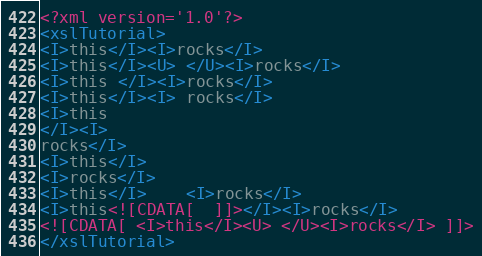Convert code to text. <code><loc_0><loc_0><loc_500><loc_500><_XML_><?xml version='1.0'?>
<xslTutorial>
<I>this</I><I>rocks</I>
<I>this</I><U> </U><I>rocks</I>
<I>this </I><I>rocks</I>
<I>this</I><I> rocks</I>
<I>this
</I><I>
rocks</I>
<I>this</I>
<I>rocks</I>
<I>this</I>	<I>rocks</I>
<I>this<![CDATA[  ]]></I><I>rocks</I>
<![CDATA[ <I>this</I><U> </U><I>rocks</I> ]]>
</xslTutorial></code> 